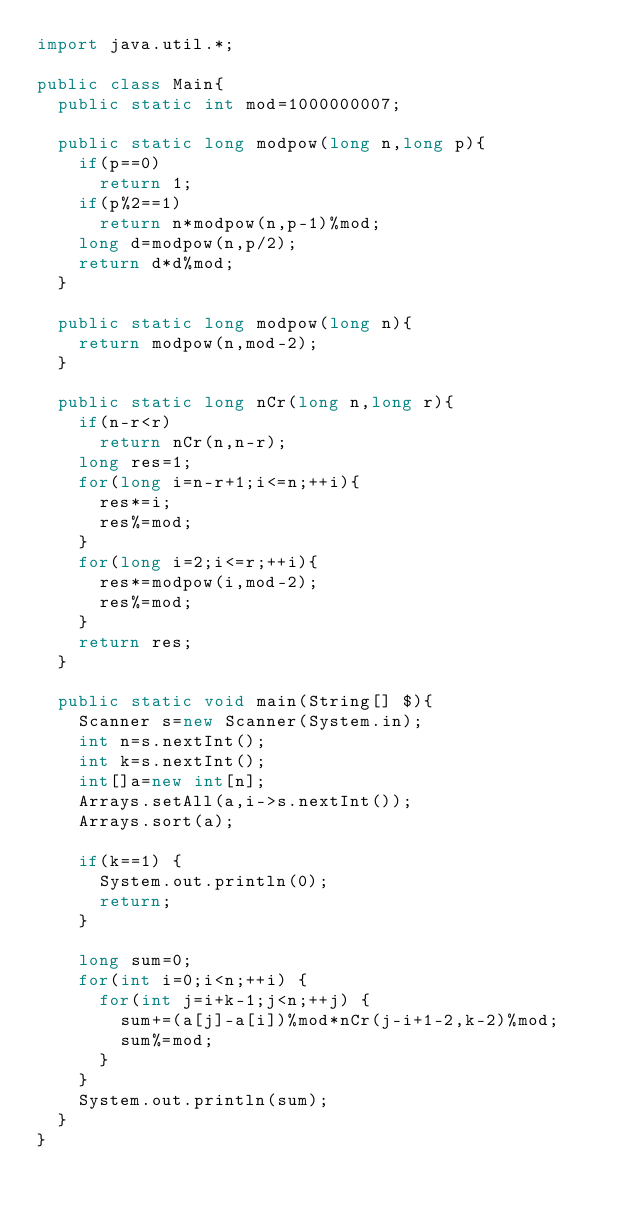<code> <loc_0><loc_0><loc_500><loc_500><_Java_>import java.util.*;

public class Main{
	public static int mod=1000000007;

	public static long modpow(long n,long p){
		if(p==0)
			return 1;
		if(p%2==1)
			return n*modpow(n,p-1)%mod;
		long d=modpow(n,p/2);
		return d*d%mod;
	}

	public static long modpow(long n){
		return modpow(n,mod-2);
	}

	public static long nCr(long n,long r){
		if(n-r<r)
			return nCr(n,n-r);
		long res=1;
		for(long i=n-r+1;i<=n;++i){
			res*=i;
			res%=mod;
		}
		for(long i=2;i<=r;++i){
			res*=modpow(i,mod-2);
			res%=mod;
		}
		return res;
	}

	public static void main(String[] $){
		Scanner s=new Scanner(System.in);
		int n=s.nextInt();
		int k=s.nextInt();
		int[]a=new int[n];
		Arrays.setAll(a,i->s.nextInt());
		Arrays.sort(a);

		if(k==1) {
			System.out.println(0);
			return;
		}

		long sum=0;
		for(int i=0;i<n;++i) {
			for(int j=i+k-1;j<n;++j) {
				sum+=(a[j]-a[i])%mod*nCr(j-i+1-2,k-2)%mod;
				sum%=mod;
			}
		}
		System.out.println(sum);
	}
}
</code> 